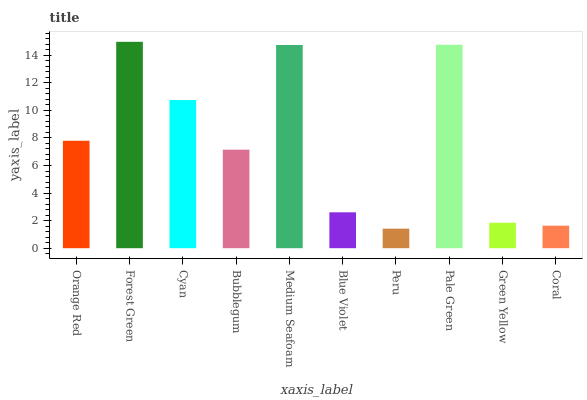Is Peru the minimum?
Answer yes or no. Yes. Is Forest Green the maximum?
Answer yes or no. Yes. Is Cyan the minimum?
Answer yes or no. No. Is Cyan the maximum?
Answer yes or no. No. Is Forest Green greater than Cyan?
Answer yes or no. Yes. Is Cyan less than Forest Green?
Answer yes or no. Yes. Is Cyan greater than Forest Green?
Answer yes or no. No. Is Forest Green less than Cyan?
Answer yes or no. No. Is Orange Red the high median?
Answer yes or no. Yes. Is Bubblegum the low median?
Answer yes or no. Yes. Is Blue Violet the high median?
Answer yes or no. No. Is Forest Green the low median?
Answer yes or no. No. 